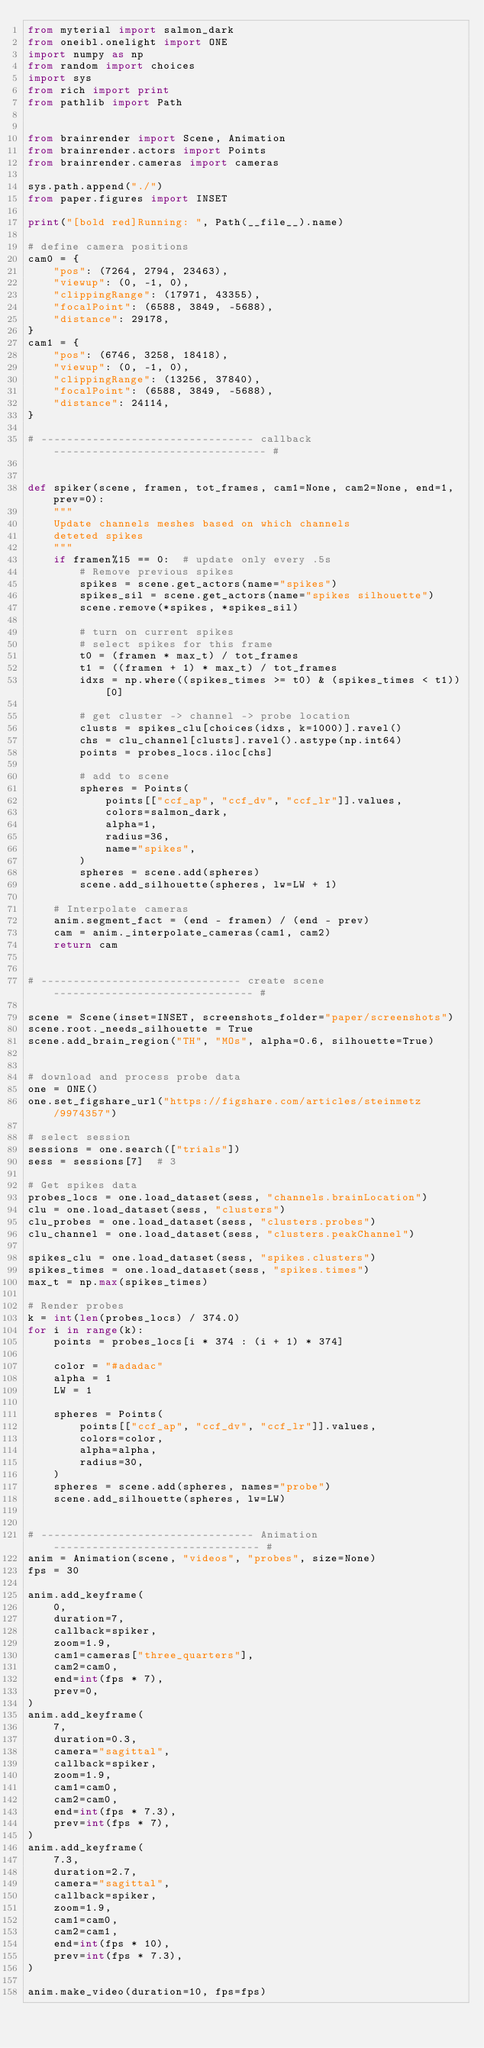<code> <loc_0><loc_0><loc_500><loc_500><_Python_>from myterial import salmon_dark
from oneibl.onelight import ONE
import numpy as np
from random import choices
import sys
from rich import print
from pathlib import Path


from brainrender import Scene, Animation
from brainrender.actors import Points
from brainrender.cameras import cameras

sys.path.append("./")
from paper.figures import INSET

print("[bold red]Running: ", Path(__file__).name)

# define camera positions
cam0 = {
    "pos": (7264, 2794, 23463),
    "viewup": (0, -1, 0),
    "clippingRange": (17971, 43355),
    "focalPoint": (6588, 3849, -5688),
    "distance": 29178,
}
cam1 = {
    "pos": (6746, 3258, 18418),
    "viewup": (0, -1, 0),
    "clippingRange": (13256, 37840),
    "focalPoint": (6588, 3849, -5688),
    "distance": 24114,
}

# --------------------------------- callback --------------------------------- #


def spiker(scene, framen, tot_frames, cam1=None, cam2=None, end=1, prev=0):
    """
    Update channels meshes based on which channels
    deteted spikes
    """
    if framen%15 == 0:  # update only every .5s
        # Remove previous spikes
        spikes = scene.get_actors(name="spikes")
        spikes_sil = scene.get_actors(name="spikes silhouette")
        scene.remove(*spikes, *spikes_sil)

        # turn on current spikes
        # select spikes for this frame
        t0 = (framen * max_t) / tot_frames
        t1 = ((framen + 1) * max_t) / tot_frames
        idxs = np.where((spikes_times >= t0) & (spikes_times < t1))[0]

        # get cluster -> channel -> probe location
        clusts = spikes_clu[choices(idxs, k=1000)].ravel()
        chs = clu_channel[clusts].ravel().astype(np.int64)
        points = probes_locs.iloc[chs]

        # add to scene
        spheres = Points(
            points[["ccf_ap", "ccf_dv", "ccf_lr"]].values,
            colors=salmon_dark,
            alpha=1,
            radius=36,
            name="spikes",
        )
        spheres = scene.add(spheres)
        scene.add_silhouette(spheres, lw=LW + 1)

    # Interpolate cameras
    anim.segment_fact = (end - framen) / (end - prev)
    cam = anim._interpolate_cameras(cam1, cam2)
    return cam


# ------------------------------- create scene ------------------------------- #

scene = Scene(inset=INSET, screenshots_folder="paper/screenshots")
scene.root._needs_silhouette = True
scene.add_brain_region("TH", "MOs", alpha=0.6, silhouette=True)


# download and process probe data
one = ONE()
one.set_figshare_url("https://figshare.com/articles/steinmetz/9974357")

# select session
sessions = one.search(["trials"])
sess = sessions[7]  # 3

# Get spikes data
probes_locs = one.load_dataset(sess, "channels.brainLocation")
clu = one.load_dataset(sess, "clusters")
clu_probes = one.load_dataset(sess, "clusters.probes")
clu_channel = one.load_dataset(sess, "clusters.peakChannel")

spikes_clu = one.load_dataset(sess, "spikes.clusters")
spikes_times = one.load_dataset(sess, "spikes.times")
max_t = np.max(spikes_times)

# Render probes
k = int(len(probes_locs) / 374.0)
for i in range(k):
    points = probes_locs[i * 374 : (i + 1) * 374]

    color = "#adadac"
    alpha = 1
    LW = 1

    spheres = Points(
        points[["ccf_ap", "ccf_dv", "ccf_lr"]].values,
        colors=color,
        alpha=alpha,
        radius=30,
    )
    spheres = scene.add(spheres, names="probe")
    scene.add_silhouette(spheres, lw=LW)


# --------------------------------- Animation -------------------------------- #
anim = Animation(scene, "videos", "probes", size=None)
fps = 30

anim.add_keyframe(
    0,
    duration=7,
    callback=spiker,
    zoom=1.9,
    cam1=cameras["three_quarters"],
    cam2=cam0,
    end=int(fps * 7),
    prev=0,
)
anim.add_keyframe(
    7,
    duration=0.3,
    camera="sagittal",
    callback=spiker,
    zoom=1.9,
    cam1=cam0,
    cam2=cam0,
    end=int(fps * 7.3),
    prev=int(fps * 7),
)
anim.add_keyframe(
    7.3,
    duration=2.7,
    camera="sagittal",
    callback=spiker,
    zoom=1.9,
    cam1=cam0,
    cam2=cam1,
    end=int(fps * 10),
    prev=int(fps * 7.3),
)

anim.make_video(duration=10, fps=fps)
</code> 